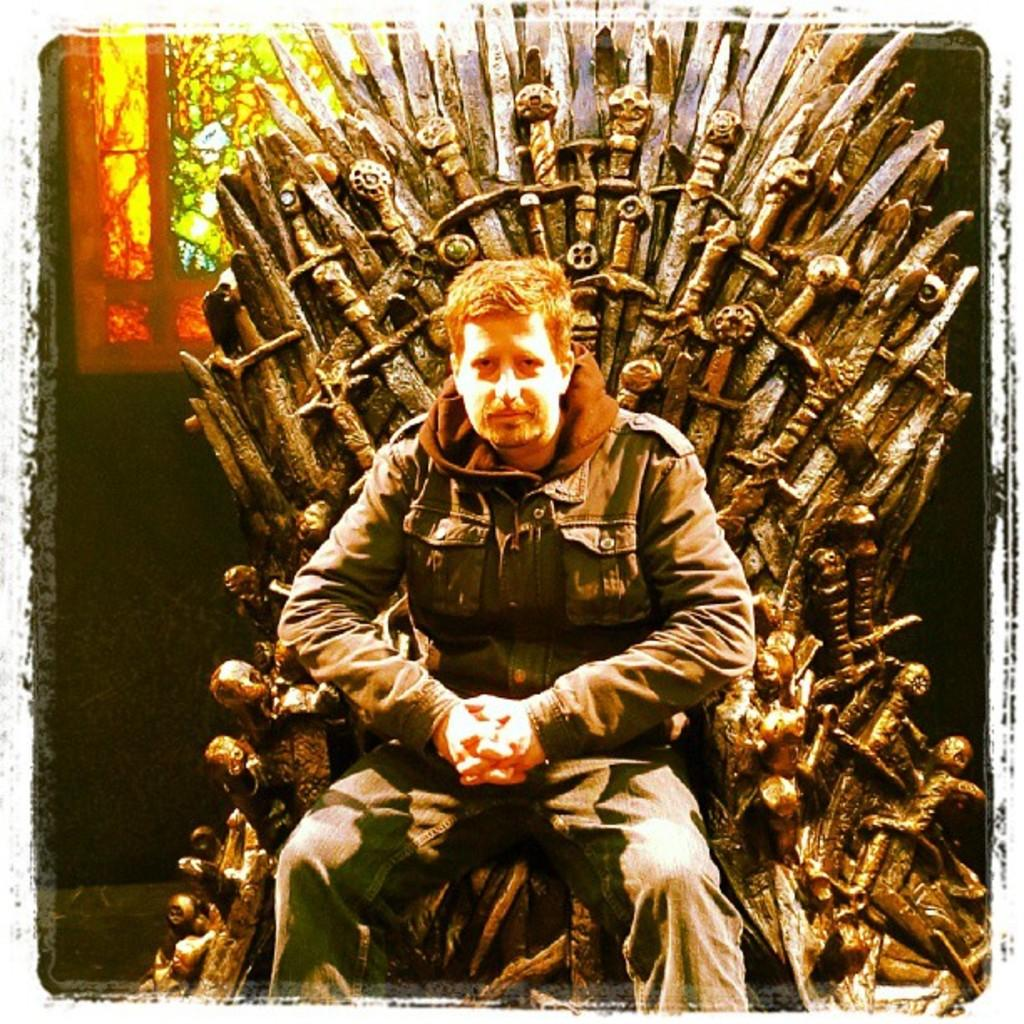What is the main subject in the foreground of the picture? There is a man in the foreground of the picture. What is the man doing in the picture? The man is sitting on a chair. What can be seen in the background of the picture? There is a wall and a window in the background of the picture. What type of orange can be seen hanging on the wall in the image? There is no orange present in the image; the wall is a background element. What is the color of the copper used to make the chair in the image? The chair in the image is not made of copper; it is not mentioned in the provided facts. 